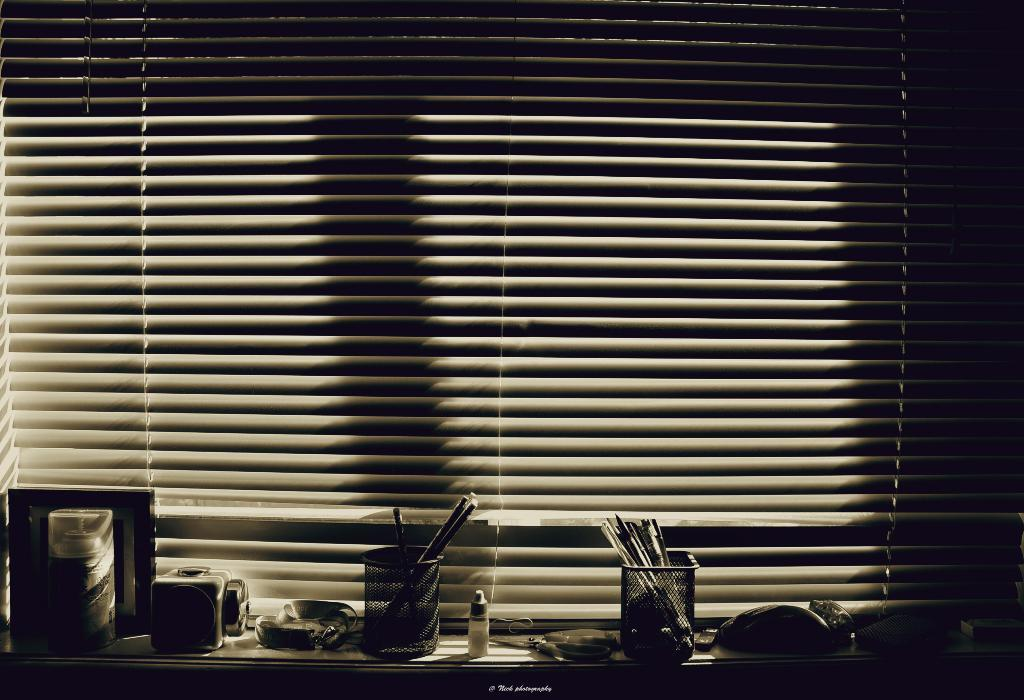What type of writing instruments are in the pen stand? There are pens in the pen stand. What is the other visible object in the image? There is a bottle visible in the image. Can you describe any other objects present in the image? Yes, there are other objects present in the image, but their specific details are not mentioned in the provided facts. What is in the background of the image? The background includes a window blind. What type of fruit is hanging from the cord in the image? There is no fruit or cord present in the image. 